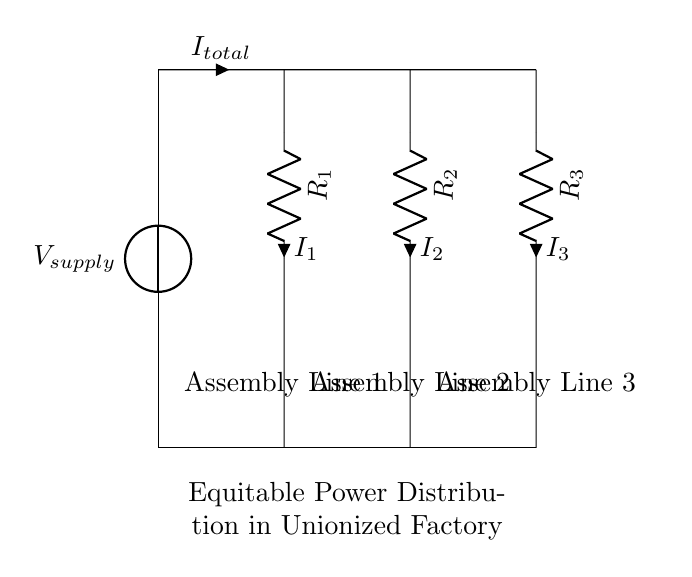What is the total current entering the circuit? The total current entering the circuit is represented by the variable \(I_{total}\), which is shown as an input in the schematic.
Answer: I_{total} What are the resistances in this circuit? The circuit has three resistances labeled \(R_1\), \(R_2\), and \(R_3\). Each of these resistors is connected in parallel, and their values are essential for determining the current division.
Answer: R_1, R_2, R_3 What is the purpose of the current divider here? The primary purpose of the current divider in this setup is to distribute the total current \(I_{total}\) among the three assembly lines based on their respective resistances.
Answer: To distribute current Which assembly line has the highest current? The assembly line with the lowest resistance will have the highest current due to the current divider principle. Without specific resistance values, we cannot definitively determine which line has the highest current, but generally, it is the line with the smallest resistance.
Answer: Assembly line with lowest resistance How does the current division depend on resistance? In a current divider, the current through each resistor is inversely proportional to its resistance. This means that lower resistance results in a higher share of the total current, and the relationship is defined by the equation \(I_n = I_{total} \times \frac{R_{total}}{R_n}\).
Answer: Inversely proportional If \(R_1\) is twice the value of \(R_2\) and \(R_3\) is equal to \(R_2\), what can be said about the distribution of currents? If \(R_1\) is twice that of \(R_2\) and \(R_3\) equals \(R_2\), it follows that \(I_1\) will be less than \(I_2\) and \(I_3\) because higher resistance means less current, demonstrating the principle of current division where larger resistances receive lesser currents.
Answer: \(I_1 < I_2 = I_3\) 